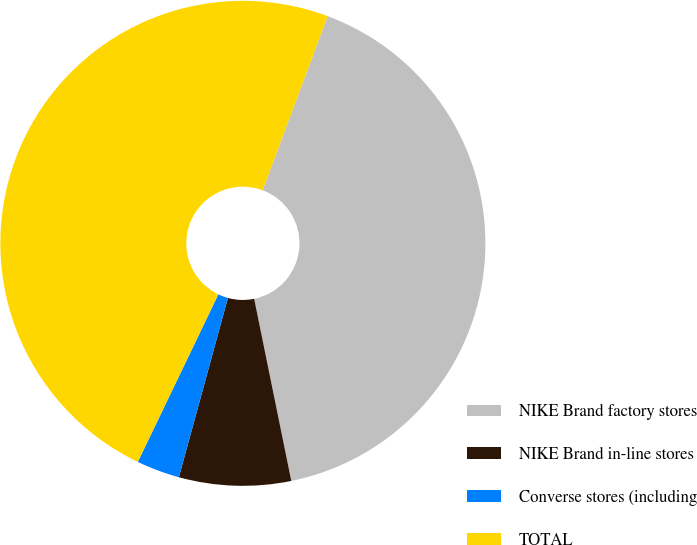Convert chart. <chart><loc_0><loc_0><loc_500><loc_500><pie_chart><fcel>NIKE Brand factory stores<fcel>NIKE Brand in-line stores<fcel>Converse stores (including<fcel>TOTAL<nl><fcel>41.12%<fcel>7.45%<fcel>2.88%<fcel>48.55%<nl></chart> 